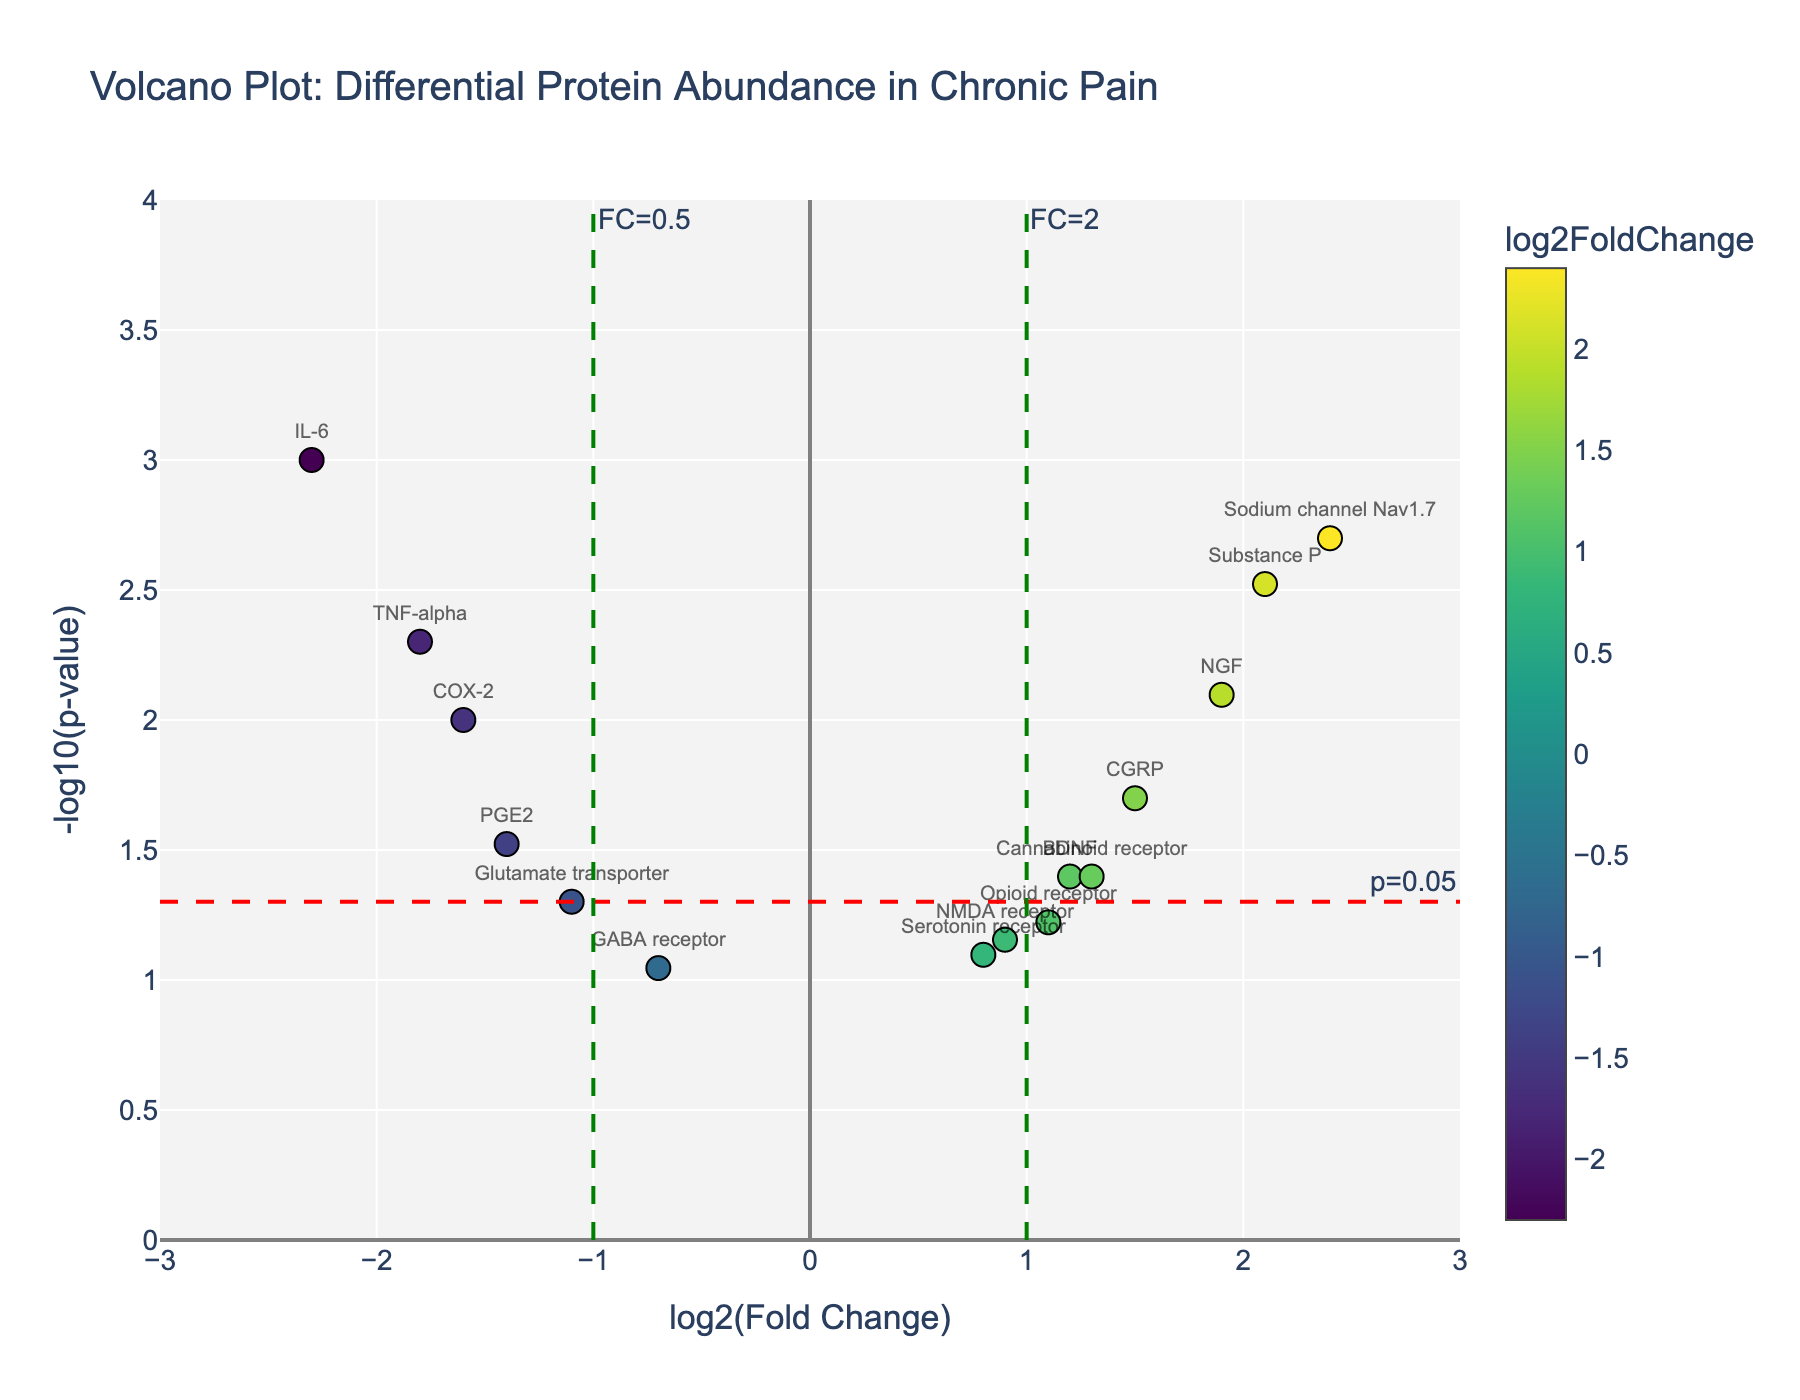What's the title of the plot? The title of the plot is usually located at the top of the figure. It summarizes the main objective of the plot. In this case, referring to the figure, we see the title "Volcano Plot: Differential Protein Abundance in Chronic Pain".
Answer: Volcano Plot: Differential Protein Abundance in Chronic Pain What do the x and y axes represent? The x-axis title is 'log2(Fold Change)', indicating it shows the logarithm base 2 of the fold change between chronic pain patients and healthy controls. The y-axis title is '-log10(p-value)', indicating it shows the negative logarithm base 10 of the p-value.
Answer: The x-axis represents log2(Fold Change) and the y-axis represents -log10(p-value) Which protein has the highest -log10(p-value)? By looking at the plot, the protein with the highest -log10(p-value) is positioned highest on the y-axis. The highest point on the y-axis corresponds to the 'IL-6' protein.
Answer: IL-6 Which proteins have a log2FoldChange greater than 2? Proteins with a log2FoldChange greater than 2 are located to the right of the vertical green line at x=2. The proteins satisfying this condition are identified by their positions in the plot and their labels. They are 'Substance P' and 'Sodium channel Nav1.7'.
Answer: Substance P, Sodium channel Nav1.7 How many proteins have p-values less than 0.05? A p-value less than 0.05 corresponds to a -log10(p-value) greater than 1.3. Count the data points above the red horizontal line at y=1.3. There are 7 such points.
Answer: 7 Which protein shows the most significant decrease in abundance in chronic pain patients? The most significant decrease in abundance will have the lowest log2FoldChange (most negative) and a significant p-value (high -log10(p-value)). The plot shows that 'IL-6' has the lowest log2FoldChange (-2.3) and a high -log10(p-value).
Answer: IL-6 Which proteins have a log2FoldChange between -1 and 1 and are not statistically significant? Non-significant proteins will have a -log10(p-value) below approximately 1.3 (corresponding to a p-value of 0.05). Locate proteins within the log2FoldChange range of -1 to 1 that are below the red horizontal line. They are 'GABA receptor', 'PGE2', 'Glutamate transporter', 'NMDA receptor', 'Serotonin receptor', and 'Opioid receptor'.
Answer: GABA receptor, PGE2, Glutamate transporter, NMDA receptor, Serotonin receptor, Opioid receptor Which protein shows the least change in abundance? The least change in abundance corresponds to the log2FoldChange closest to 0. On the plot, the protein with log2FoldChange nearest to 0 is the 'GABA receptor'.
Answer: GABA receptor Compare 'TNF-alpha' and 'COX-2'. Which one is more significantly downregulated? Downregulation means negative log2FoldChange. 'TNF-alpha' has a log2FoldChange of -1.8 and -log10(p-value) of 2.3. 'COX-2' has a log2FoldChange of -1.6 and -log10(p-value) of 2.0. Since -1.8 is less than -1.6, 'TNF-alpha' is more significantly downregulated.
Answer: TNF-alpha 